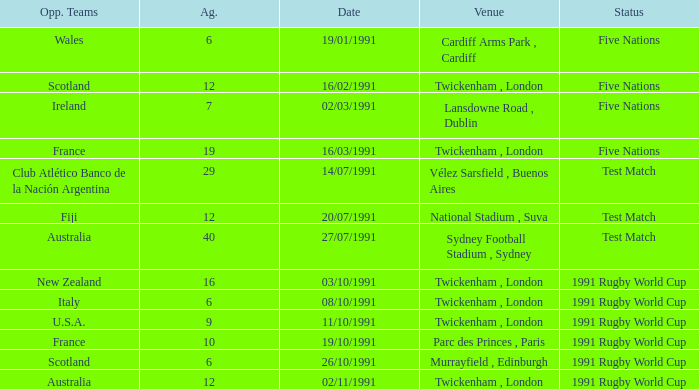What is Opposing Teams, when Date is "11/10/1991"? U.S.A. 